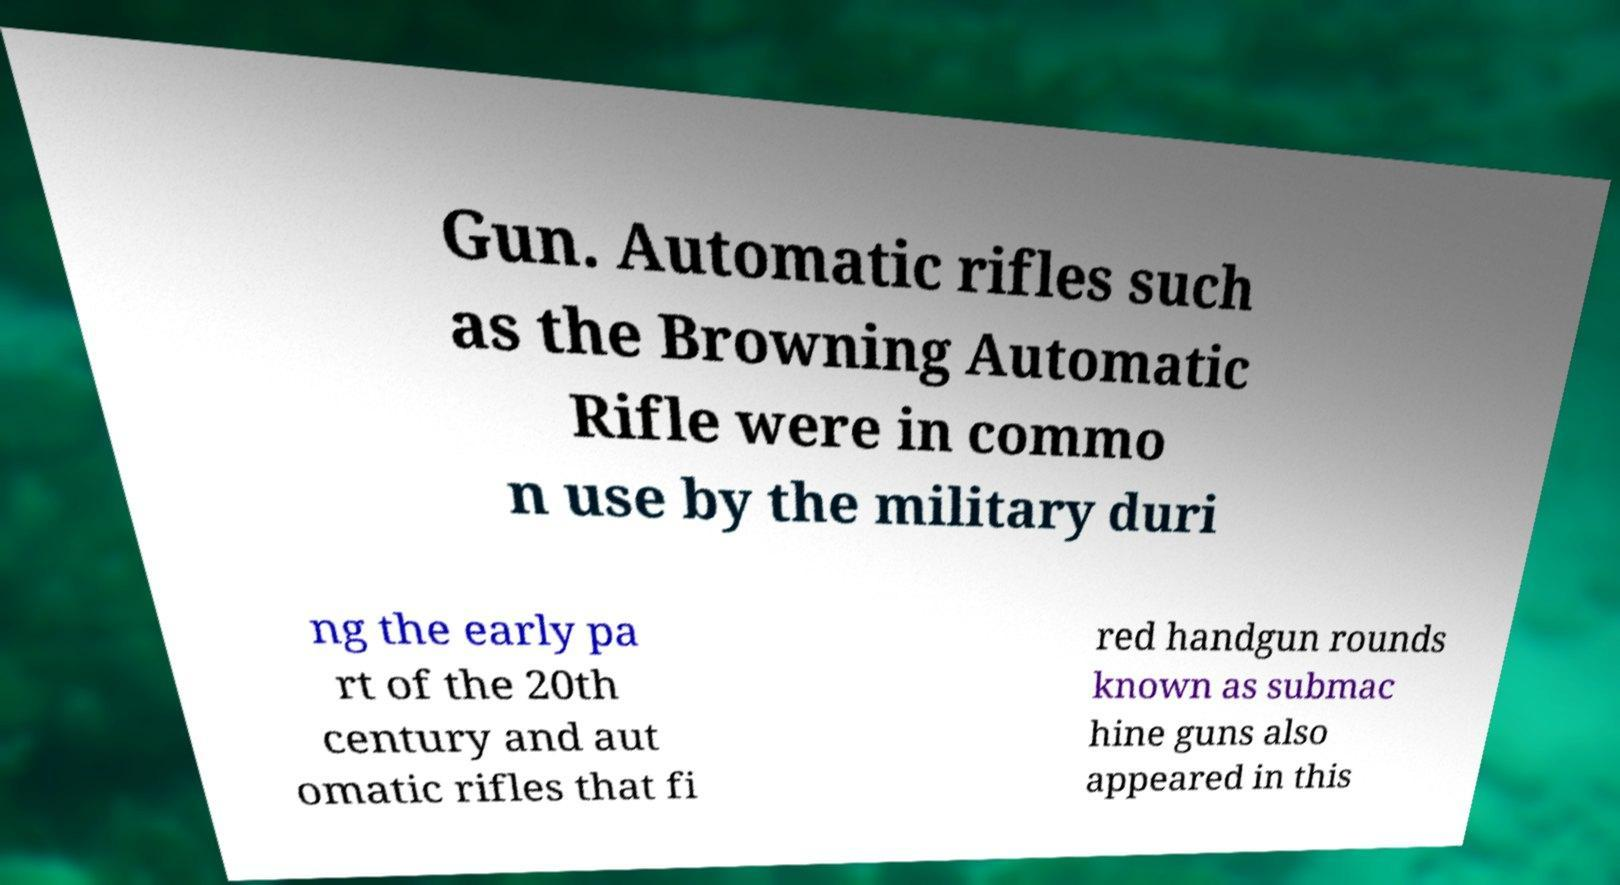I need the written content from this picture converted into text. Can you do that? Gun. Automatic rifles such as the Browning Automatic Rifle were in commo n use by the military duri ng the early pa rt of the 20th century and aut omatic rifles that fi red handgun rounds known as submac hine guns also appeared in this 